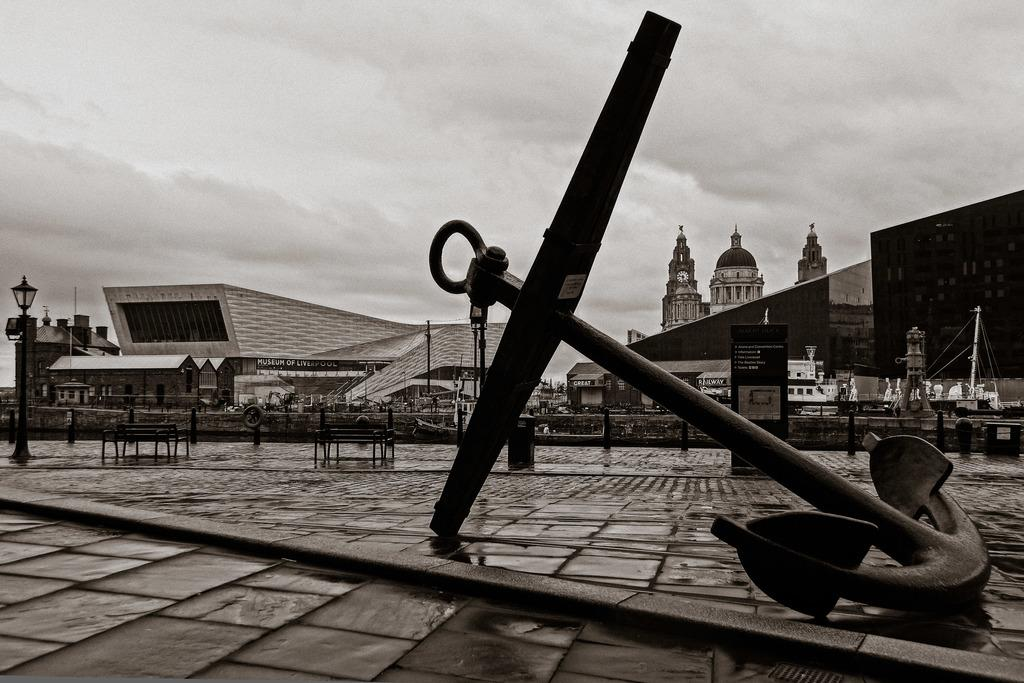What is the main object in the image? There is an anchor in the image. What can be seen in the background of the image? There are buildings, light poles, banners, and the sky visible in the background of the image. What is the color scheme of the image? The image is in black and white. What type of celery can be seen growing on the farm in the image? There is no celery or farm present in the image; it features an anchor and background elements. Is the image based on a fictional story or event? The image does not appear to be based on a fictional story or event, as it features an anchor and background elements in a realistic setting. 